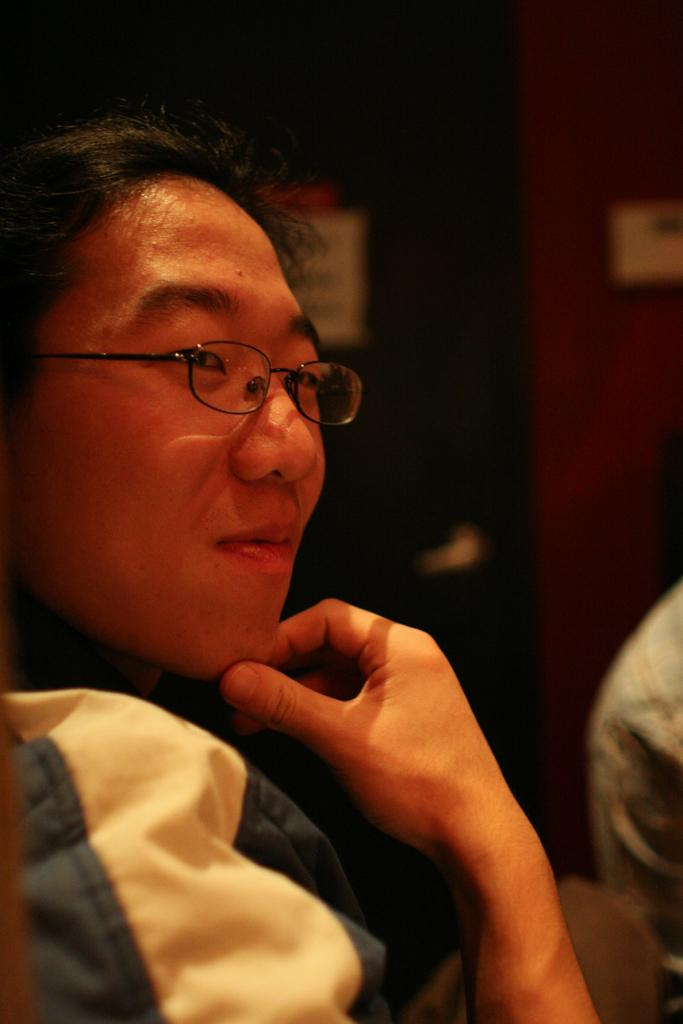What is the main subject of the image? There is a person in the image. What can be observed about the person's appearance? The person is wearing specs. How would you describe the background of the image? The background of the image is blurry. How many cakes can be seen on the road in the image? There is no road or cake present in the image. 